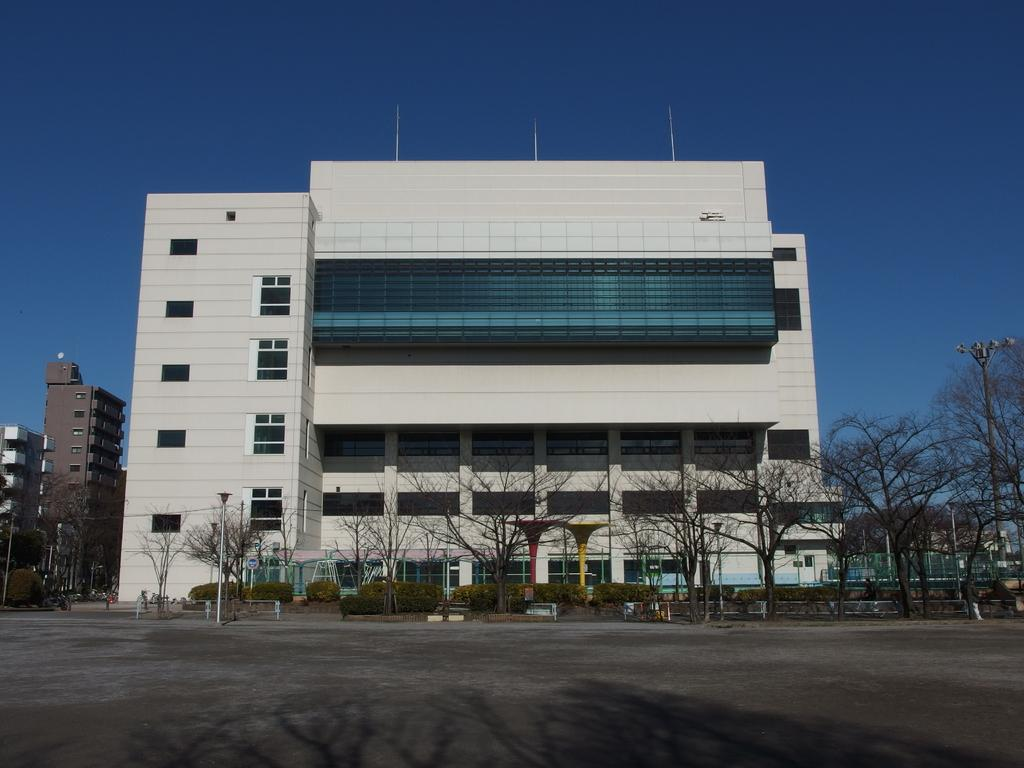What type of structures are present in the image? There are buildings in the image. What type of vegetation can be seen in the image? There are trees and plants in the image. What type of lighting is present in the image? There is a street light in the image. What type of pathway is visible in the image? There is a road in front of the building in the image. What can be seen in the background of the image? The sky is visible in the background of the image. What type of cabbage is being used as a decoration on the building in the image? There is no cabbage present in the image; it features buildings, trees, plants, a street light, a road, and the sky. What event is taking place in front of the building in the image? There is no event taking place in front of the building in the image; it simply shows a road and the building. 